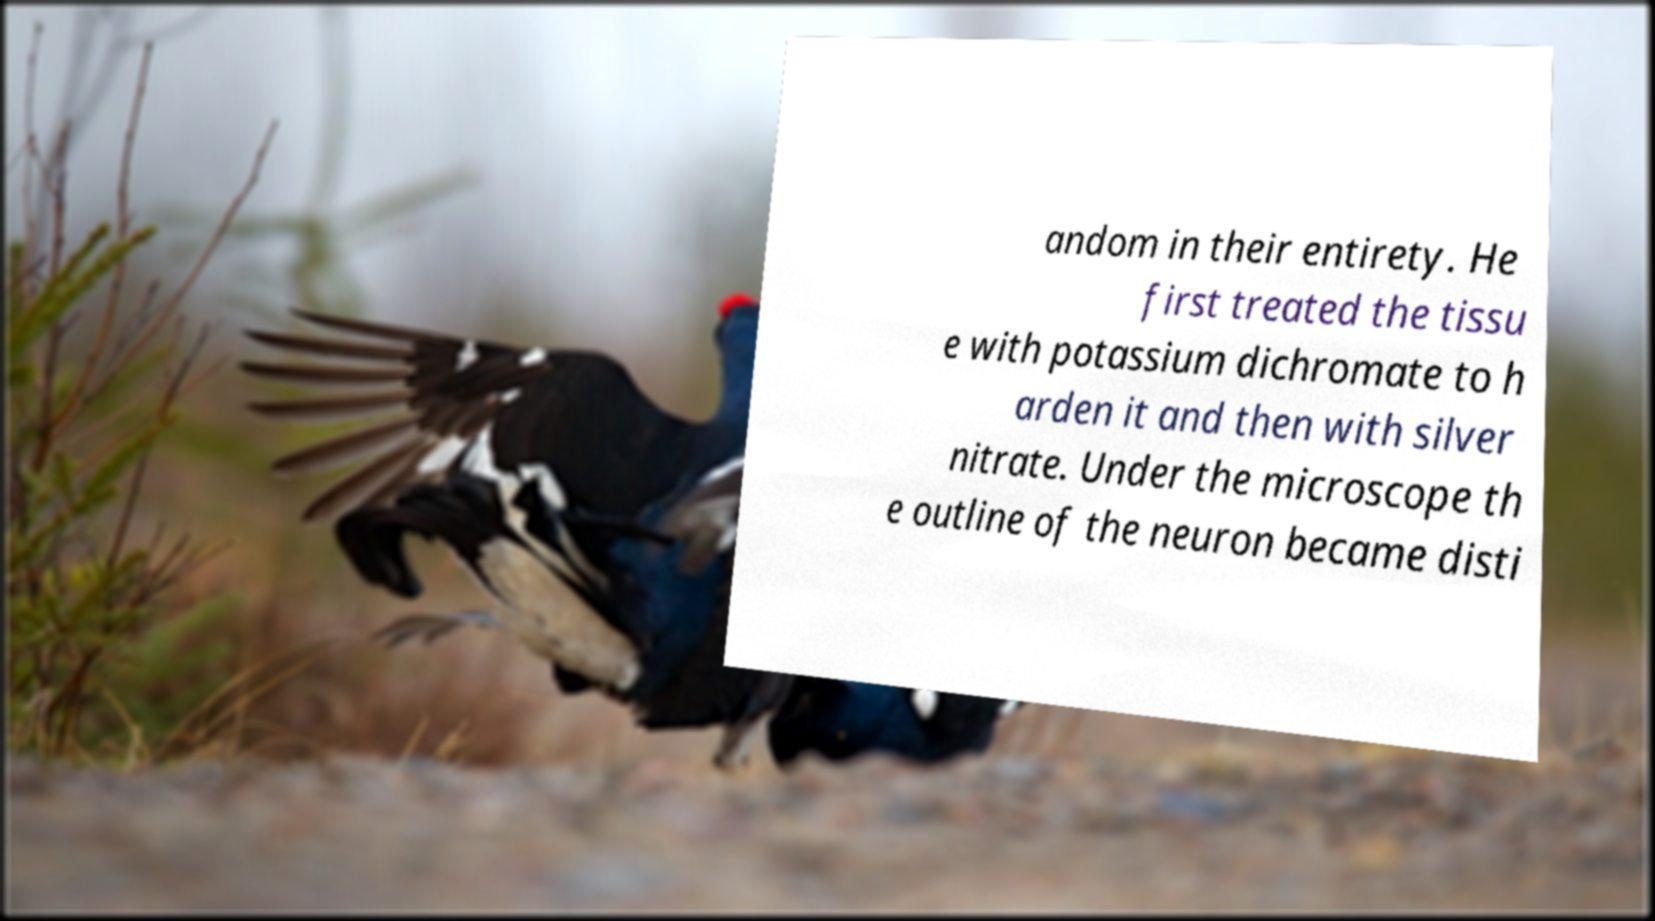What messages or text are displayed in this image? I need them in a readable, typed format. andom in their entirety. He first treated the tissu e with potassium dichromate to h arden it and then with silver nitrate. Under the microscope th e outline of the neuron became disti 